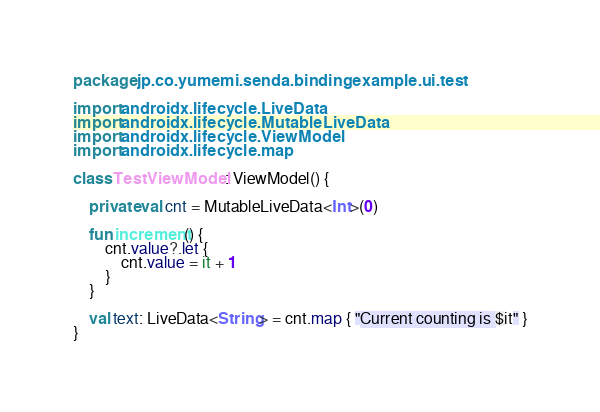<code> <loc_0><loc_0><loc_500><loc_500><_Kotlin_>package jp.co.yumemi.senda.bindingexample.ui.test

import androidx.lifecycle.LiveData
import androidx.lifecycle.MutableLiveData
import androidx.lifecycle.ViewModel
import androidx.lifecycle.map

class TestViewModel : ViewModel() {

    private val cnt = MutableLiveData<Int>(0)

    fun increment() {
        cnt.value?.let {
            cnt.value = it + 1
        }
    }

    val text: LiveData<String> = cnt.map { "Current counting is $it" }
}
</code> 